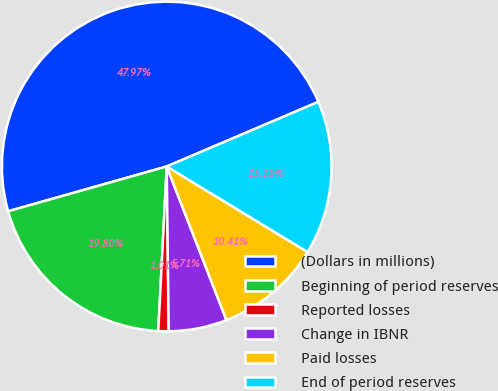<chart> <loc_0><loc_0><loc_500><loc_500><pie_chart><fcel>(Dollars in millions)<fcel>Beginning of period reserves<fcel>Reported losses<fcel>Change in IBNR<fcel>Paid losses<fcel>End of period reserves<nl><fcel>47.97%<fcel>19.8%<fcel>1.01%<fcel>5.71%<fcel>10.41%<fcel>15.1%<nl></chart> 